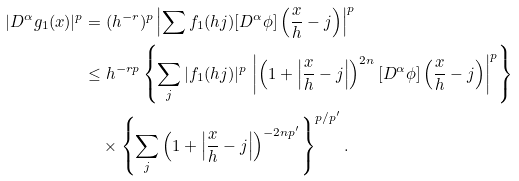Convert formula to latex. <formula><loc_0><loc_0><loc_500><loc_500>| D ^ { \alpha } g _ { 1 } ( x ) | ^ { p } & = ( h ^ { - r } ) ^ { p } \left | \sum f _ { 1 } ( h j ) [ D ^ { \alpha } \phi ] \left ( \frac { x } h - j \right ) \right | ^ { p } \\ & \leq h ^ { - r p } \left \{ \sum _ { j } | f _ { 1 } ( h j ) | ^ { p } \, \left | \left ( 1 + \left | \frac { x } h - j \right | \right ) ^ { 2 n } [ D ^ { \alpha } \phi ] \left ( \frac { x } h - j \right ) \right | ^ { p } \right \} \\ & \quad \times \left \{ \sum _ { j } \left ( 1 + \left | \frac { x } h - j \right | \right ) ^ { - 2 n p ^ { \prime } } \right \} ^ { p / p ^ { \prime } } .</formula> 